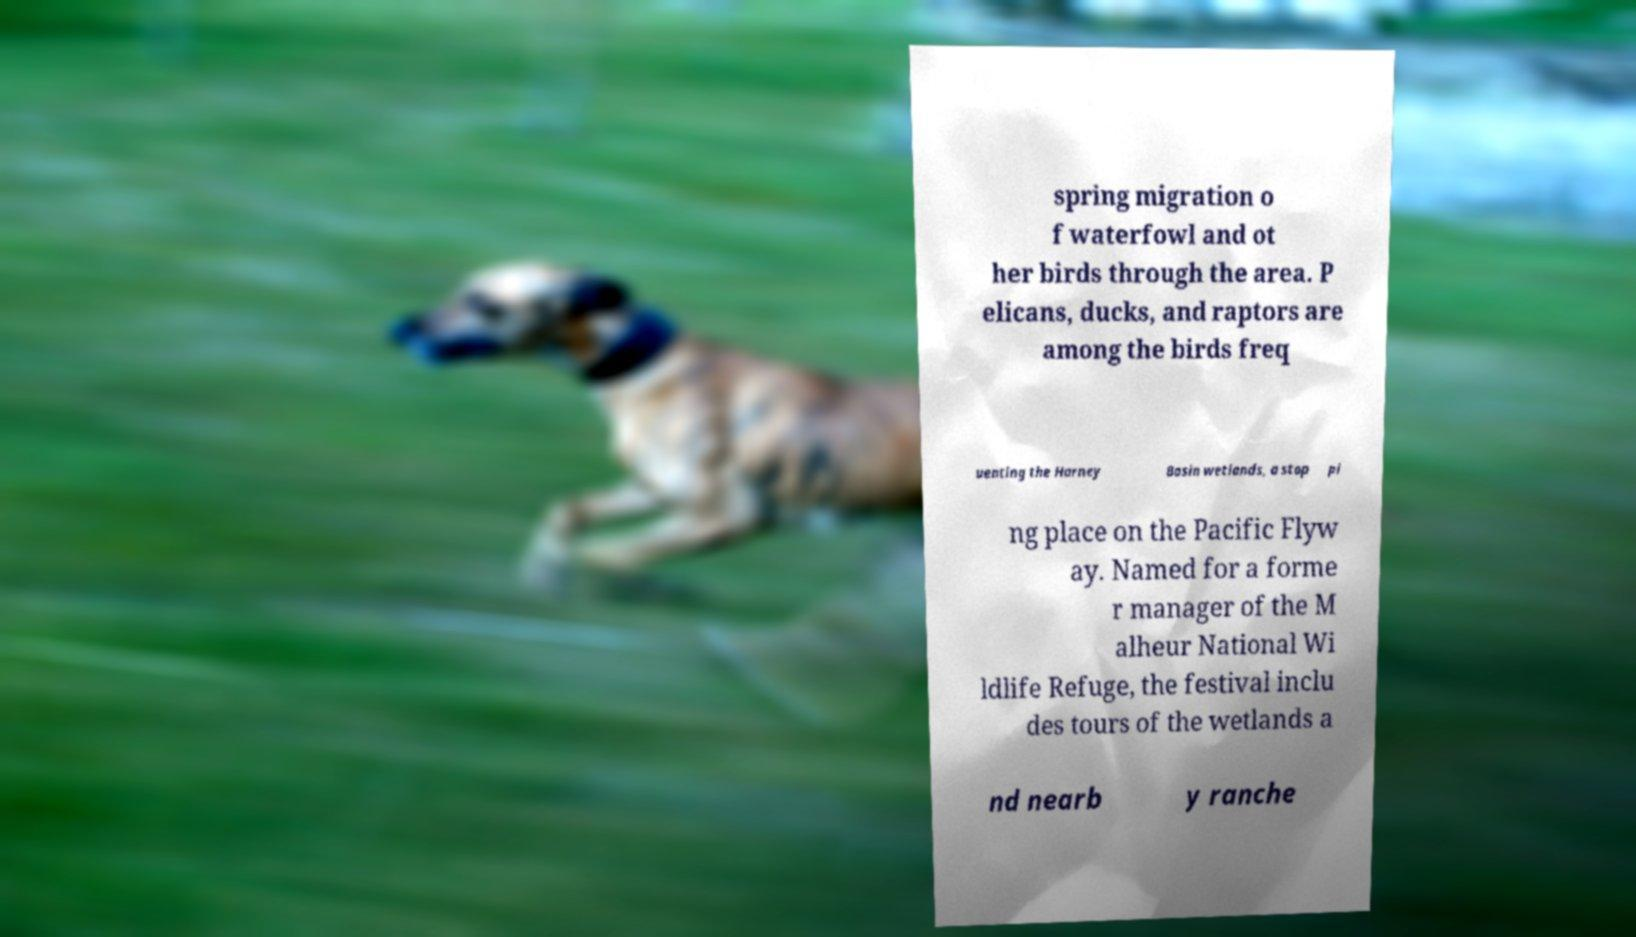Please read and relay the text visible in this image. What does it say? spring migration o f waterfowl and ot her birds through the area. P elicans, ducks, and raptors are among the birds freq uenting the Harney Basin wetlands, a stop pi ng place on the Pacific Flyw ay. Named for a forme r manager of the M alheur National Wi ldlife Refuge, the festival inclu des tours of the wetlands a nd nearb y ranche 